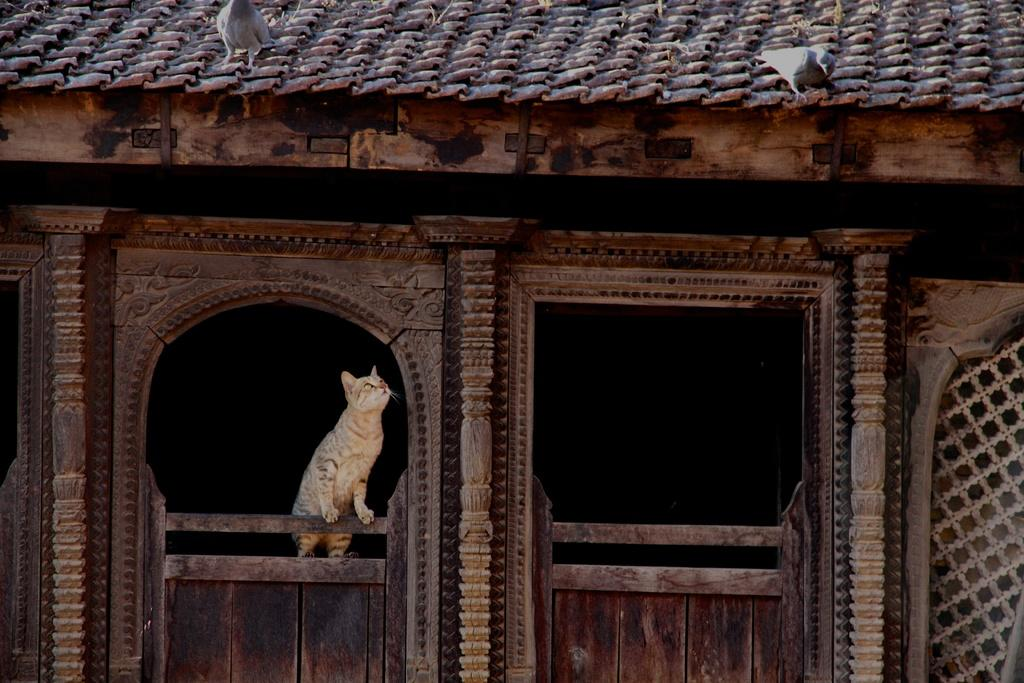What type of animal is in the image? There is a cat in the image. Where is the cat positioned? The cat is standing on a wall. What other animals are in the image? There are pigeons in the image. Where are the pigeons located? The pigeons are on a rooftop. What type of lace is being used to create a story in the image? There is no lace or story present in the image; it features a cat standing on a wall and pigeons on a rooftop. 